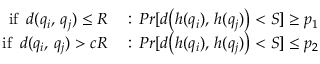<formula> <loc_0><loc_0><loc_500><loc_500>\begin{array} { r l } { i f \, d ( q _ { i } , \, q _ { j } ) \leq R } & \colon \, P r [ d \left ( h ( q _ { i } ) , \, h ( q _ { j } ) \right ) < S ] \geq p _ { 1 } } \\ { i f \, d ( q _ { i } , \, q _ { j } ) > c R } & \colon \, P r [ d \left ( h ( q _ { i } ) , \, h ( q _ { j } ) \right ) < S ] \leq p _ { 2 } } \end{array}</formula> 